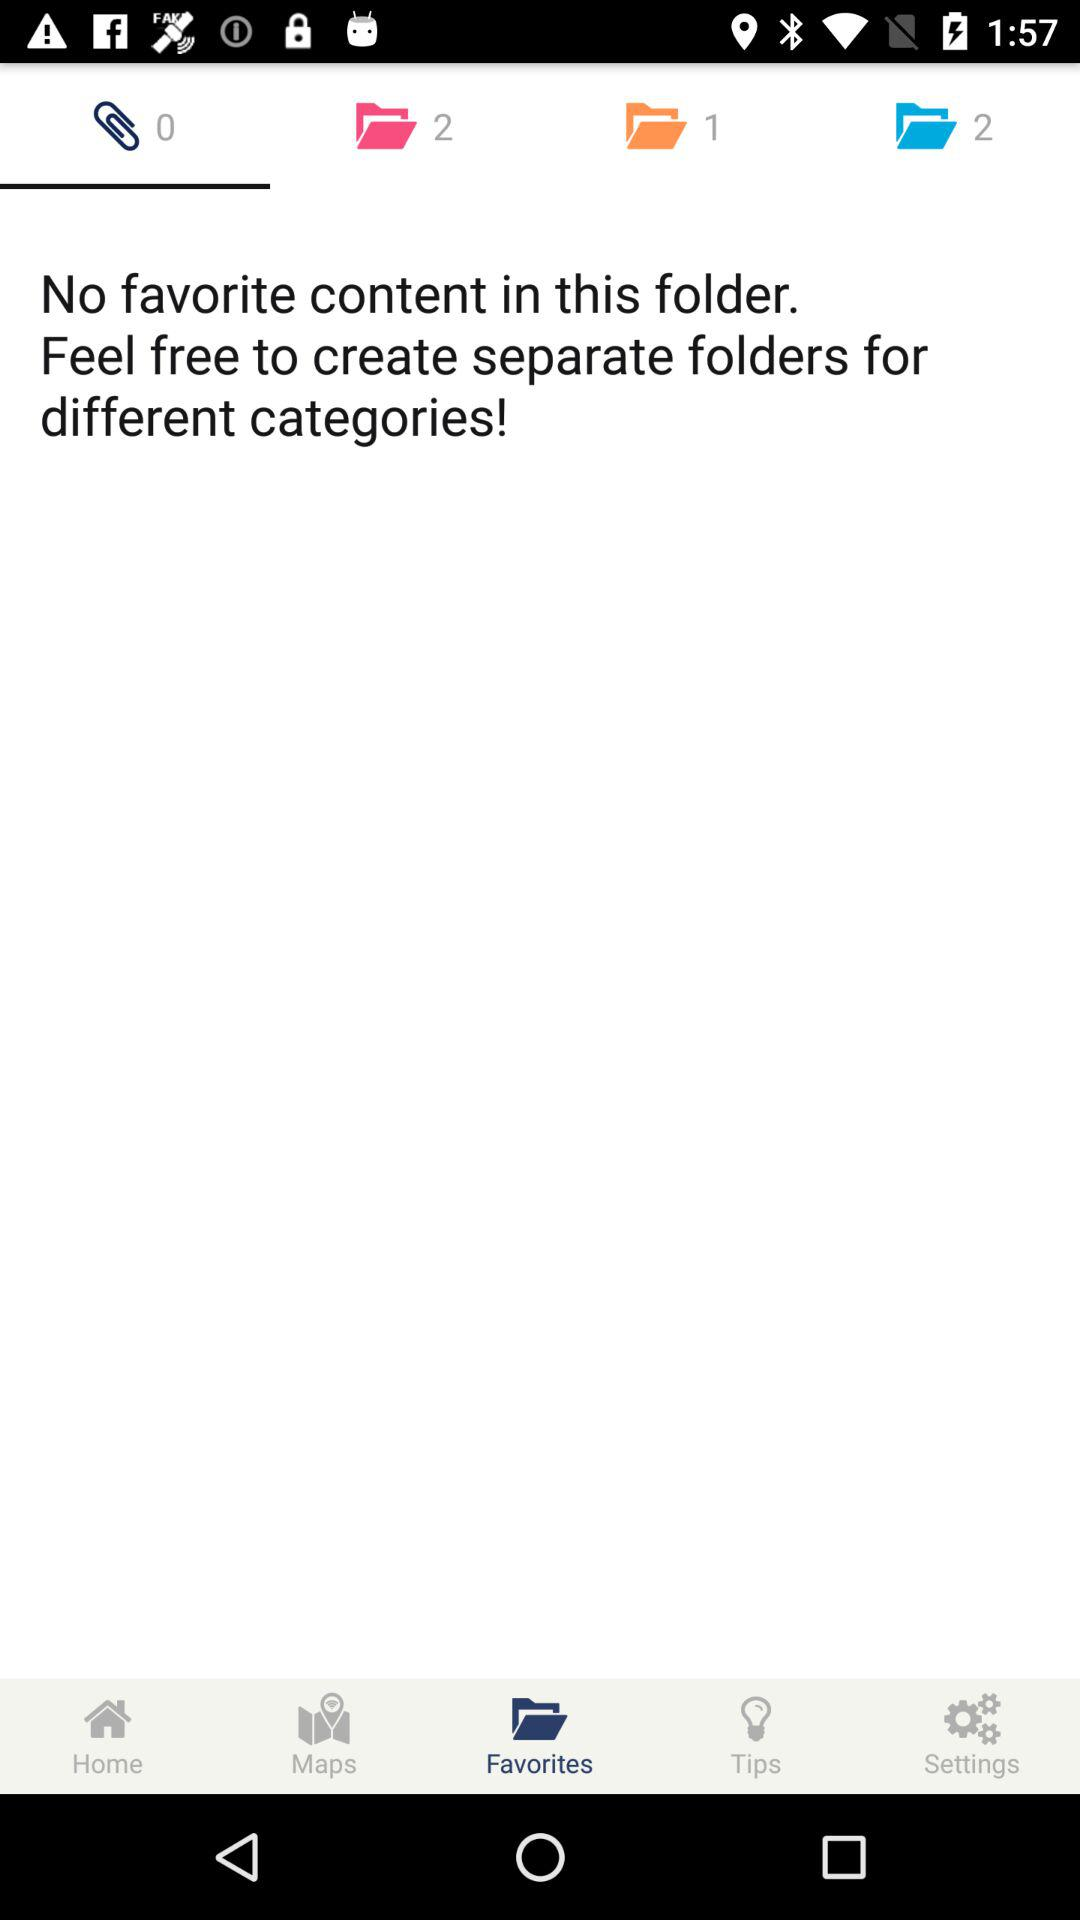How can we create separate folders for different categories?
When the provided information is insufficient, respond with <no answer>. <no answer> 